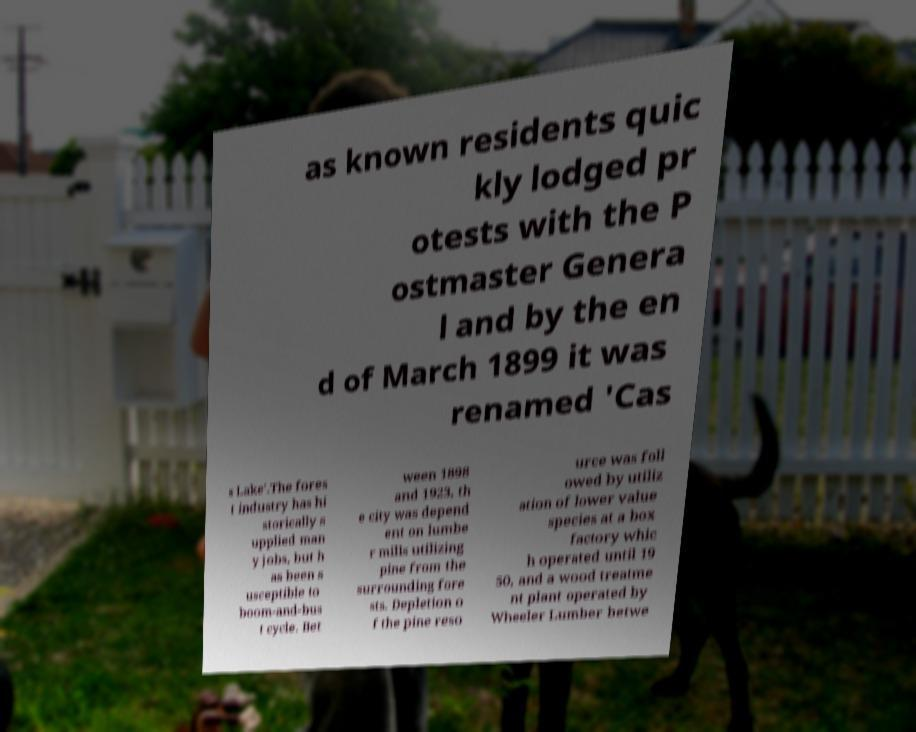Can you read and provide the text displayed in the image?This photo seems to have some interesting text. Can you extract and type it out for me? as known residents quic kly lodged pr otests with the P ostmaster Genera l and by the en d of March 1899 it was renamed 'Cas s Lake'.The fores t industry has hi storically s upplied man y jobs, but h as been s usceptible to boom-and-bus t cycle. Bet ween 1898 and 1923, th e city was depend ent on lumbe r mills utilizing pine from the surrounding fore sts. Depletion o f the pine reso urce was foll owed by utiliz ation of lower value species at a box factory whic h operated until 19 50, and a wood treatme nt plant operated by Wheeler Lumber betwe 